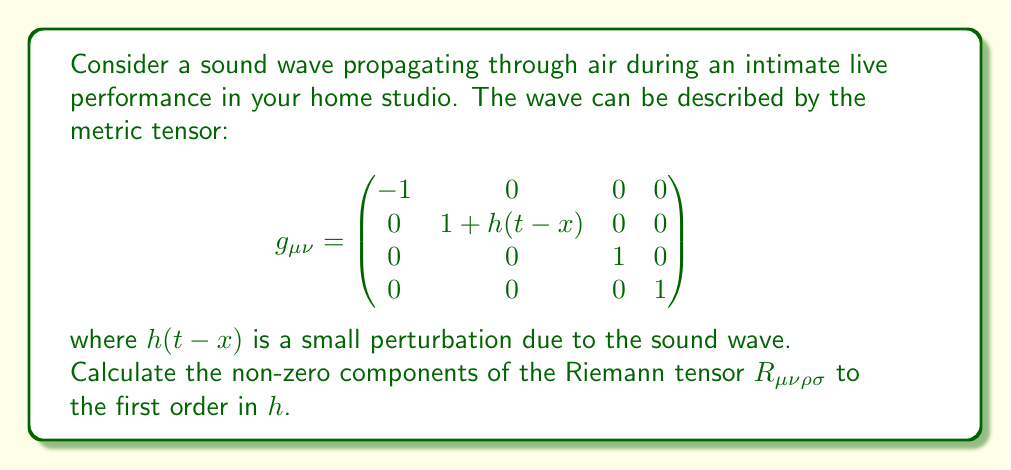Can you solve this math problem? Let's approach this step-by-step:

1) The Riemann tensor is given by:

   $$R^\mu_{\;\;\nu\rho\sigma} = \partial_\rho \Gamma^\mu_{\nu\sigma} - \partial_\sigma \Gamma^\mu_{\nu\rho} + \Gamma^\mu_{\lambda\rho}\Gamma^\lambda_{\nu\sigma} - \Gamma^\mu_{\lambda\sigma}\Gamma^\lambda_{\nu\rho}$$

2) First, we need to calculate the Christoffel symbols $\Gamma^\mu_{\nu\sigma}$. They are given by:

   $$\Gamma^\mu_{\nu\sigma} = \frac{1}{2}g^{\mu\lambda}(\partial_\nu g_{\lambda\sigma} + \partial_\sigma g_{\lambda\nu} - \partial_\lambda g_{\nu\sigma})$$

3) The inverse metric to first order in $h$ is:

   $$g^{\mu\nu} = \begin{pmatrix}
   -1 & 0 & 0 & 0 \\
   0 & 1-h(t-x) & 0 & 0 \\
   0 & 0 & 1 & 0 \\
   0 & 0 & 0 & 1
   \end{pmatrix}$$

4) Calculating the non-zero Christoffel symbols to first order in $h$:

   $$\Gamma^1_{11} = \Gamma^1_{00} = -\frac{1}{2}h'(t-x)$$
   $$\Gamma^0_{01} = \Gamma^0_{10} = \frac{1}{2}h'(t-x)$$

   where $h'$ denotes the derivative of $h$ with respect to its argument.

5) Now, we can calculate the non-zero components of the Riemann tensor:

   $$R^1_{\;\;010} = \partial_1 \Gamma^1_{00} - \partial_0 \Gamma^1_{10} = -\frac{1}{2}h''(t-x)$$
   $$R^0_{\;\;101} = \partial_0 \Gamma^0_{11} - \partial_1 \Gamma^0_{01} = -\frac{1}{2}h''(t-x)$$

6) The corresponding covariant components are:

   $$R_{1010} = g_{11}R^1_{\;\;010} = (1+h(t-x))(-\frac{1}{2}h''(t-x)) \approx -\frac{1}{2}h''(t-x)$$
   $$R_{0101} = g_{00}R^0_{\;\;101} = -(-\frac{1}{2}h''(t-x)) = \frac{1}{2}h''(t-x)$$

   to first order in $h$.

7) All other components are either zero or related to these by symmetry.
Answer: $R_{1010} = -\frac{1}{2}h''(t-x)$, $R_{0101} = \frac{1}{2}h''(t-x)$ 